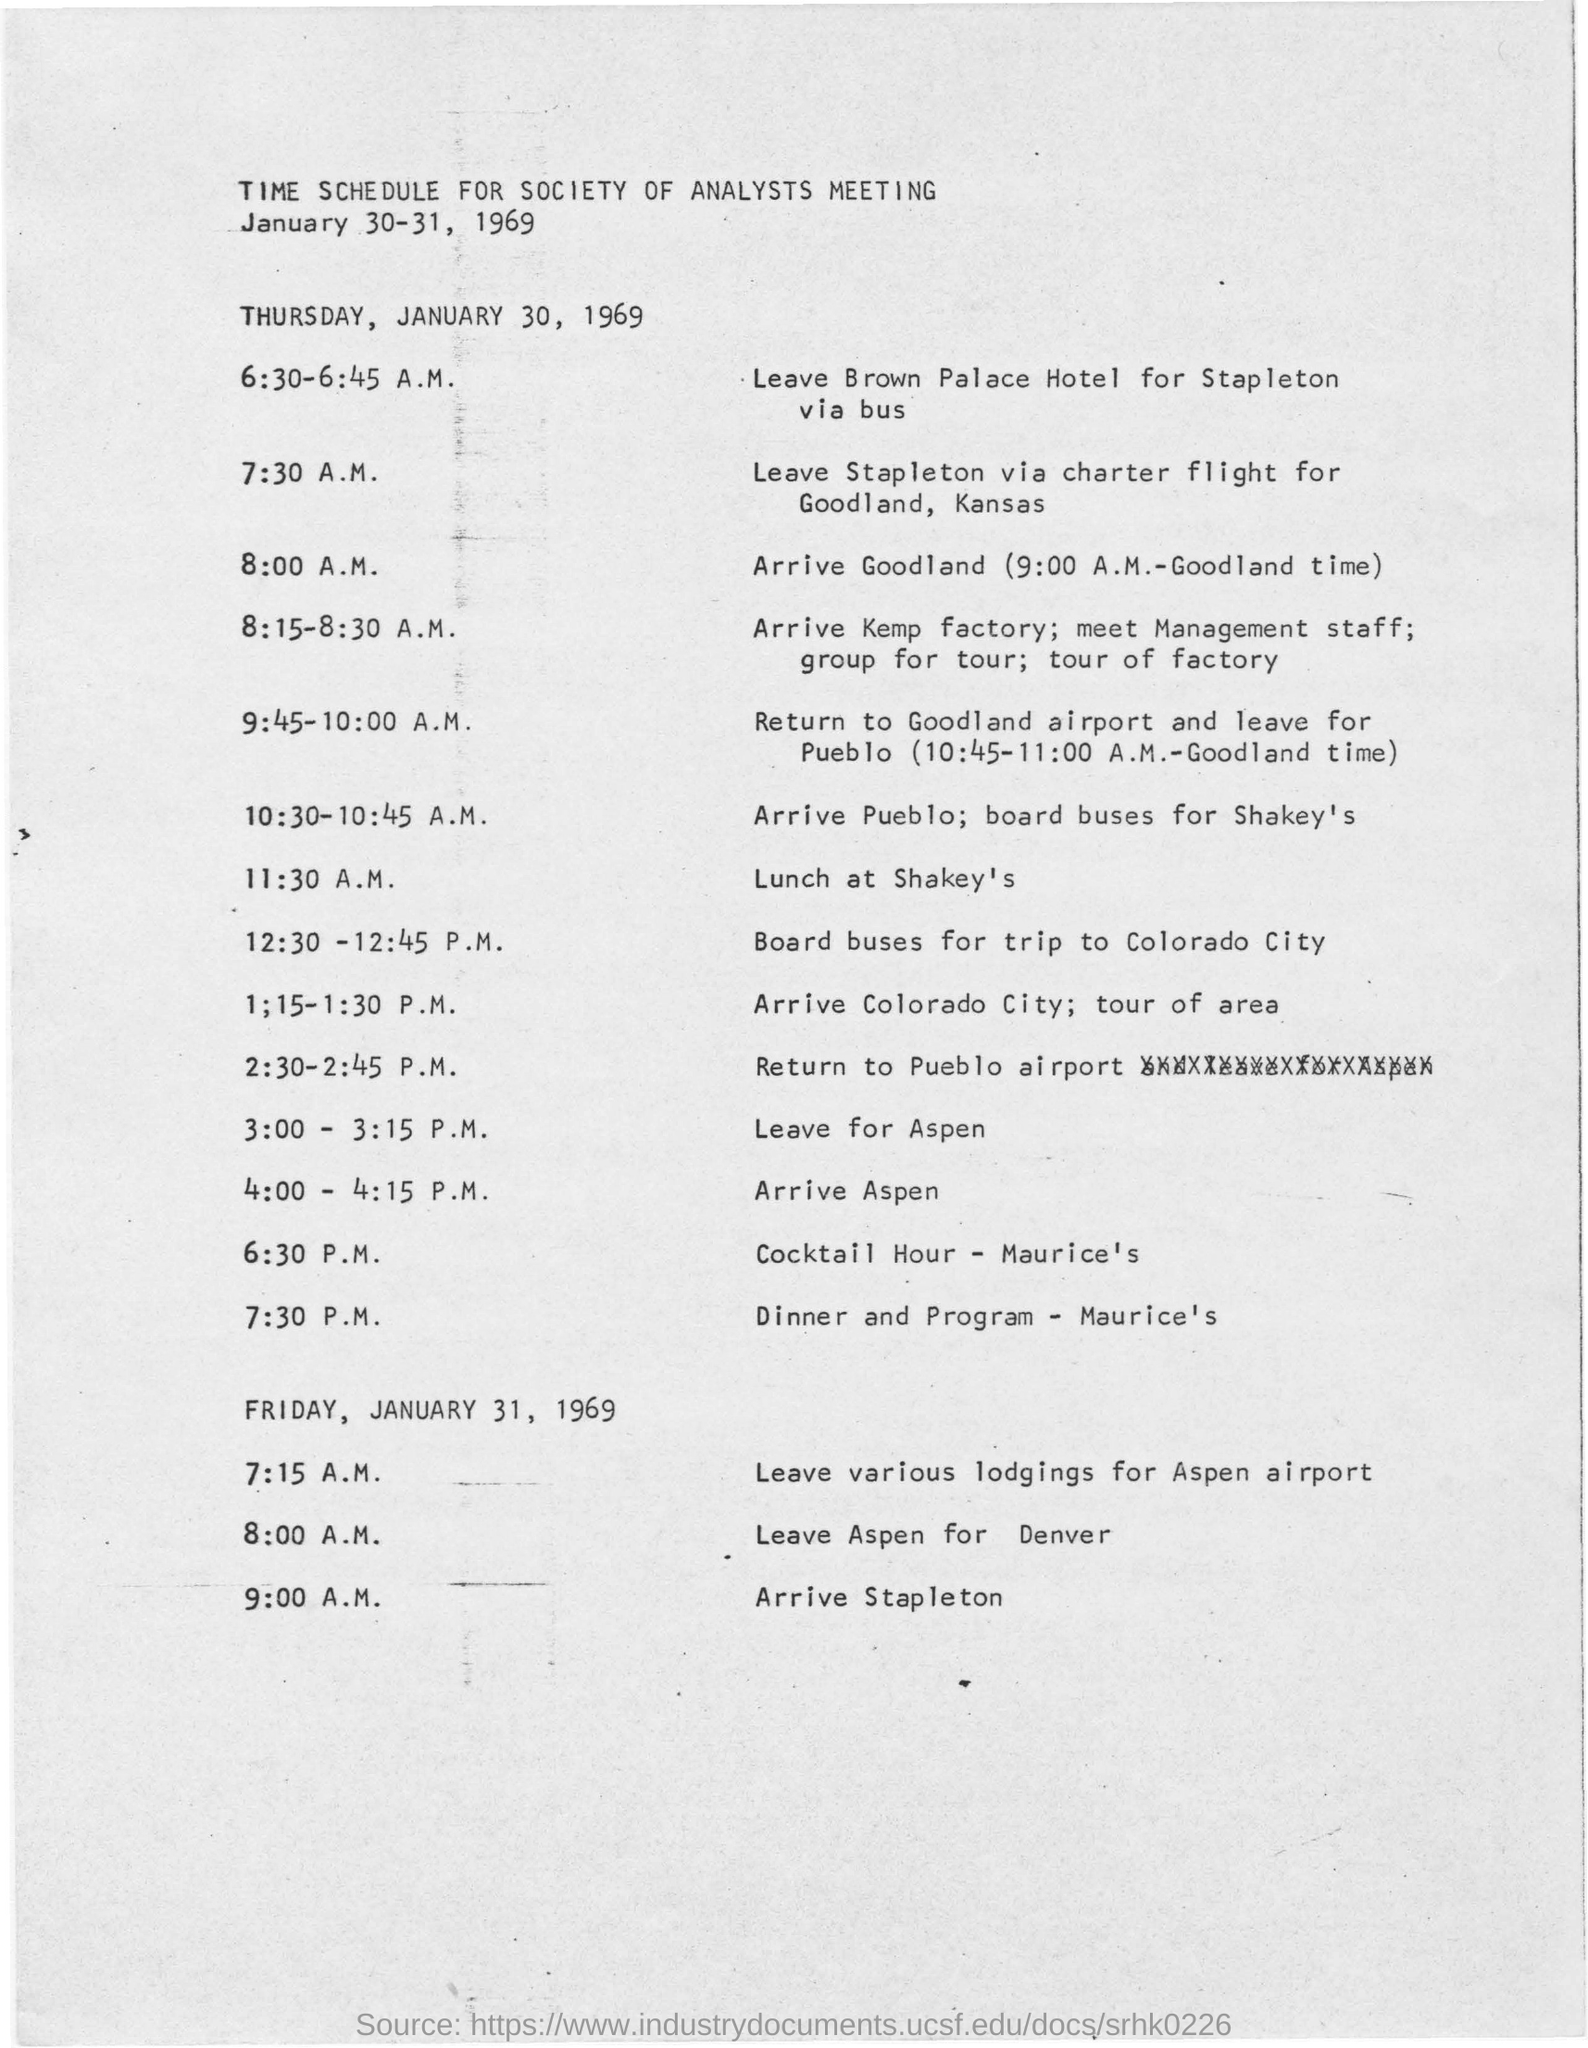What date is the Society of Analysts Meeting held?
Provide a succinct answer. January 30-31, 1969. Where is the lunch scheduled at?
Offer a very short reply. At shakey's. 